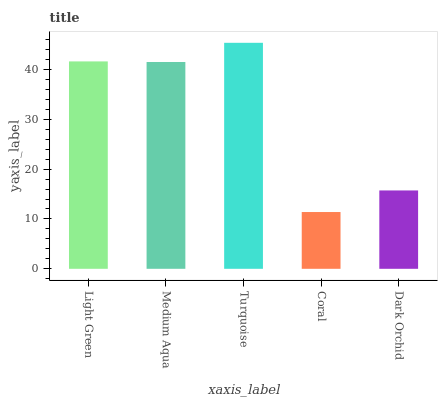Is Medium Aqua the minimum?
Answer yes or no. No. Is Medium Aqua the maximum?
Answer yes or no. No. Is Light Green greater than Medium Aqua?
Answer yes or no. Yes. Is Medium Aqua less than Light Green?
Answer yes or no. Yes. Is Medium Aqua greater than Light Green?
Answer yes or no. No. Is Light Green less than Medium Aqua?
Answer yes or no. No. Is Medium Aqua the high median?
Answer yes or no. Yes. Is Medium Aqua the low median?
Answer yes or no. Yes. Is Light Green the high median?
Answer yes or no. No. Is Dark Orchid the low median?
Answer yes or no. No. 